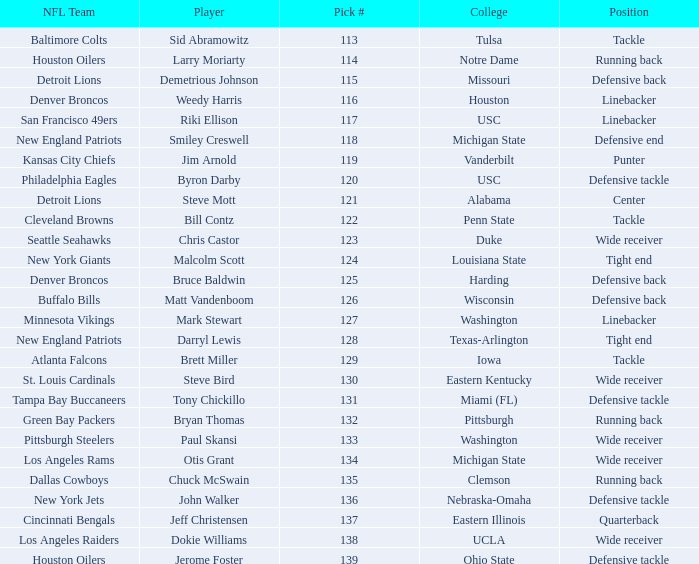What pick number did the buffalo bills get? 126.0. 